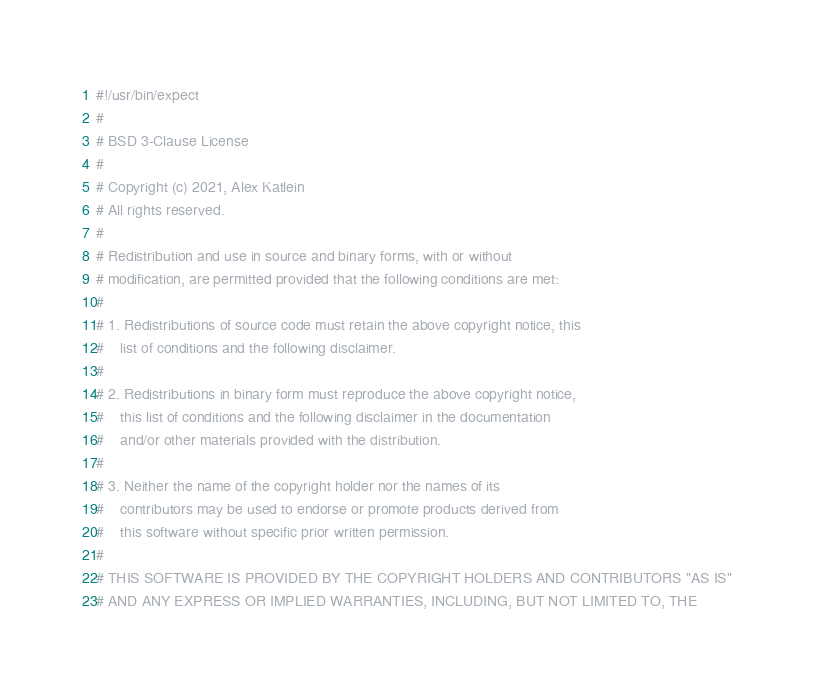Convert code to text. <code><loc_0><loc_0><loc_500><loc_500><_Bash_>#!/usr/bin/expect
#
# BSD 3-Clause License
#
# Copyright (c) 2021, Alex Katlein
# All rights reserved.
#
# Redistribution and use in source and binary forms, with or without
# modification, are permitted provided that the following conditions are met:
#
# 1. Redistributions of source code must retain the above copyright notice, this
#    list of conditions and the following disclaimer.
#
# 2. Redistributions in binary form must reproduce the above copyright notice,
#    this list of conditions and the following disclaimer in the documentation
#    and/or other materials provided with the distribution.
#
# 3. Neither the name of the copyright holder nor the names of its
#    contributors may be used to endorse or promote products derived from
#    this software without specific prior written permission.
#
# THIS SOFTWARE IS PROVIDED BY THE COPYRIGHT HOLDERS AND CONTRIBUTORS "AS IS"
# AND ANY EXPRESS OR IMPLIED WARRANTIES, INCLUDING, BUT NOT LIMITED TO, THE</code> 